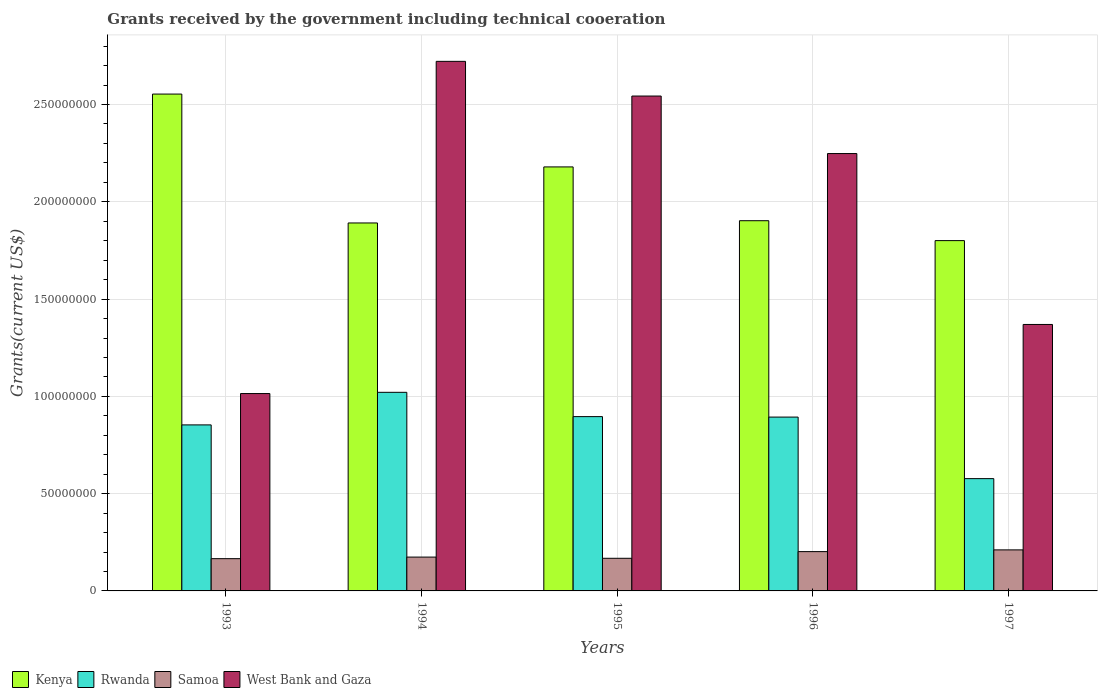How many different coloured bars are there?
Give a very brief answer. 4. How many groups of bars are there?
Make the answer very short. 5. What is the label of the 3rd group of bars from the left?
Offer a terse response. 1995. In how many cases, is the number of bars for a given year not equal to the number of legend labels?
Provide a succinct answer. 0. What is the total grants received by the government in West Bank and Gaza in 1996?
Ensure brevity in your answer.  2.25e+08. Across all years, what is the maximum total grants received by the government in Kenya?
Your answer should be compact. 2.55e+08. Across all years, what is the minimum total grants received by the government in Samoa?
Ensure brevity in your answer.  1.66e+07. In which year was the total grants received by the government in Kenya maximum?
Make the answer very short. 1993. What is the total total grants received by the government in Kenya in the graph?
Make the answer very short. 1.03e+09. What is the difference between the total grants received by the government in West Bank and Gaza in 1994 and that in 1997?
Offer a terse response. 1.35e+08. What is the difference between the total grants received by the government in Samoa in 1993 and the total grants received by the government in West Bank and Gaza in 1997?
Give a very brief answer. -1.20e+08. What is the average total grants received by the government in Samoa per year?
Keep it short and to the point. 1.84e+07. In the year 1994, what is the difference between the total grants received by the government in Rwanda and total grants received by the government in Kenya?
Your answer should be very brief. -8.70e+07. What is the ratio of the total grants received by the government in Samoa in 1995 to that in 1997?
Offer a terse response. 0.8. Is the total grants received by the government in Samoa in 1993 less than that in 1996?
Your answer should be compact. Yes. Is the difference between the total grants received by the government in Rwanda in 1994 and 1997 greater than the difference between the total grants received by the government in Kenya in 1994 and 1997?
Ensure brevity in your answer.  Yes. What is the difference between the highest and the second highest total grants received by the government in Rwanda?
Provide a short and direct response. 1.25e+07. What is the difference between the highest and the lowest total grants received by the government in Kenya?
Give a very brief answer. 7.53e+07. In how many years, is the total grants received by the government in Samoa greater than the average total grants received by the government in Samoa taken over all years?
Provide a short and direct response. 2. Is it the case that in every year, the sum of the total grants received by the government in Kenya and total grants received by the government in Rwanda is greater than the sum of total grants received by the government in Samoa and total grants received by the government in West Bank and Gaza?
Offer a very short reply. No. What does the 3rd bar from the left in 1993 represents?
Offer a terse response. Samoa. What does the 4th bar from the right in 1993 represents?
Provide a short and direct response. Kenya. How many bars are there?
Keep it short and to the point. 20. What is the difference between two consecutive major ticks on the Y-axis?
Make the answer very short. 5.00e+07. Are the values on the major ticks of Y-axis written in scientific E-notation?
Keep it short and to the point. No. Does the graph contain grids?
Ensure brevity in your answer.  Yes. What is the title of the graph?
Make the answer very short. Grants received by the government including technical cooeration. What is the label or title of the X-axis?
Give a very brief answer. Years. What is the label or title of the Y-axis?
Make the answer very short. Grants(current US$). What is the Grants(current US$) in Kenya in 1993?
Your answer should be compact. 2.55e+08. What is the Grants(current US$) in Rwanda in 1993?
Your response must be concise. 8.53e+07. What is the Grants(current US$) in Samoa in 1993?
Your answer should be very brief. 1.66e+07. What is the Grants(current US$) in West Bank and Gaza in 1993?
Make the answer very short. 1.01e+08. What is the Grants(current US$) in Kenya in 1994?
Your answer should be very brief. 1.89e+08. What is the Grants(current US$) in Rwanda in 1994?
Give a very brief answer. 1.02e+08. What is the Grants(current US$) of Samoa in 1994?
Provide a short and direct response. 1.74e+07. What is the Grants(current US$) of West Bank and Gaza in 1994?
Make the answer very short. 2.72e+08. What is the Grants(current US$) in Kenya in 1995?
Offer a terse response. 2.18e+08. What is the Grants(current US$) of Rwanda in 1995?
Ensure brevity in your answer.  8.96e+07. What is the Grants(current US$) in Samoa in 1995?
Provide a succinct answer. 1.68e+07. What is the Grants(current US$) in West Bank and Gaza in 1995?
Provide a succinct answer. 2.54e+08. What is the Grants(current US$) in Kenya in 1996?
Provide a succinct answer. 1.90e+08. What is the Grants(current US$) of Rwanda in 1996?
Offer a very short reply. 8.94e+07. What is the Grants(current US$) in Samoa in 1996?
Your answer should be very brief. 2.02e+07. What is the Grants(current US$) in West Bank and Gaza in 1996?
Give a very brief answer. 2.25e+08. What is the Grants(current US$) of Kenya in 1997?
Provide a short and direct response. 1.80e+08. What is the Grants(current US$) in Rwanda in 1997?
Offer a terse response. 5.77e+07. What is the Grants(current US$) of Samoa in 1997?
Provide a short and direct response. 2.11e+07. What is the Grants(current US$) in West Bank and Gaza in 1997?
Your answer should be compact. 1.37e+08. Across all years, what is the maximum Grants(current US$) in Kenya?
Provide a succinct answer. 2.55e+08. Across all years, what is the maximum Grants(current US$) in Rwanda?
Provide a succinct answer. 1.02e+08. Across all years, what is the maximum Grants(current US$) of Samoa?
Make the answer very short. 2.11e+07. Across all years, what is the maximum Grants(current US$) of West Bank and Gaza?
Provide a succinct answer. 2.72e+08. Across all years, what is the minimum Grants(current US$) of Kenya?
Provide a succinct answer. 1.80e+08. Across all years, what is the minimum Grants(current US$) in Rwanda?
Provide a short and direct response. 5.77e+07. Across all years, what is the minimum Grants(current US$) of Samoa?
Your answer should be compact. 1.66e+07. Across all years, what is the minimum Grants(current US$) of West Bank and Gaza?
Make the answer very short. 1.01e+08. What is the total Grants(current US$) in Kenya in the graph?
Provide a succinct answer. 1.03e+09. What is the total Grants(current US$) in Rwanda in the graph?
Offer a terse response. 4.24e+08. What is the total Grants(current US$) in Samoa in the graph?
Your response must be concise. 9.20e+07. What is the total Grants(current US$) in West Bank and Gaza in the graph?
Give a very brief answer. 9.90e+08. What is the difference between the Grants(current US$) of Kenya in 1993 and that in 1994?
Provide a short and direct response. 6.62e+07. What is the difference between the Grants(current US$) in Rwanda in 1993 and that in 1994?
Offer a very short reply. -1.67e+07. What is the difference between the Grants(current US$) in Samoa in 1993 and that in 1994?
Give a very brief answer. -8.10e+05. What is the difference between the Grants(current US$) of West Bank and Gaza in 1993 and that in 1994?
Offer a very short reply. -1.71e+08. What is the difference between the Grants(current US$) in Kenya in 1993 and that in 1995?
Provide a succinct answer. 3.74e+07. What is the difference between the Grants(current US$) of Rwanda in 1993 and that in 1995?
Your response must be concise. -4.25e+06. What is the difference between the Grants(current US$) in Samoa in 1993 and that in 1995?
Give a very brief answer. -1.90e+05. What is the difference between the Grants(current US$) in West Bank and Gaza in 1993 and that in 1995?
Provide a succinct answer. -1.53e+08. What is the difference between the Grants(current US$) in Kenya in 1993 and that in 1996?
Keep it short and to the point. 6.51e+07. What is the difference between the Grants(current US$) in Rwanda in 1993 and that in 1996?
Your response must be concise. -4.01e+06. What is the difference between the Grants(current US$) of Samoa in 1993 and that in 1996?
Provide a short and direct response. -3.62e+06. What is the difference between the Grants(current US$) in West Bank and Gaza in 1993 and that in 1996?
Provide a short and direct response. -1.23e+08. What is the difference between the Grants(current US$) in Kenya in 1993 and that in 1997?
Ensure brevity in your answer.  7.53e+07. What is the difference between the Grants(current US$) of Rwanda in 1993 and that in 1997?
Provide a succinct answer. 2.76e+07. What is the difference between the Grants(current US$) of Samoa in 1993 and that in 1997?
Your response must be concise. -4.51e+06. What is the difference between the Grants(current US$) of West Bank and Gaza in 1993 and that in 1997?
Your answer should be very brief. -3.55e+07. What is the difference between the Grants(current US$) of Kenya in 1994 and that in 1995?
Keep it short and to the point. -2.88e+07. What is the difference between the Grants(current US$) of Rwanda in 1994 and that in 1995?
Offer a very short reply. 1.25e+07. What is the difference between the Grants(current US$) of Samoa in 1994 and that in 1995?
Your answer should be very brief. 6.20e+05. What is the difference between the Grants(current US$) of West Bank and Gaza in 1994 and that in 1995?
Ensure brevity in your answer.  1.78e+07. What is the difference between the Grants(current US$) in Kenya in 1994 and that in 1996?
Make the answer very short. -1.16e+06. What is the difference between the Grants(current US$) of Rwanda in 1994 and that in 1996?
Give a very brief answer. 1.27e+07. What is the difference between the Grants(current US$) of Samoa in 1994 and that in 1996?
Give a very brief answer. -2.81e+06. What is the difference between the Grants(current US$) of West Bank and Gaza in 1994 and that in 1996?
Give a very brief answer. 4.74e+07. What is the difference between the Grants(current US$) in Kenya in 1994 and that in 1997?
Your answer should be compact. 9.07e+06. What is the difference between the Grants(current US$) in Rwanda in 1994 and that in 1997?
Provide a succinct answer. 4.44e+07. What is the difference between the Grants(current US$) of Samoa in 1994 and that in 1997?
Offer a very short reply. -3.70e+06. What is the difference between the Grants(current US$) in West Bank and Gaza in 1994 and that in 1997?
Provide a short and direct response. 1.35e+08. What is the difference between the Grants(current US$) in Kenya in 1995 and that in 1996?
Keep it short and to the point. 2.76e+07. What is the difference between the Grants(current US$) in Samoa in 1995 and that in 1996?
Offer a very short reply. -3.43e+06. What is the difference between the Grants(current US$) in West Bank and Gaza in 1995 and that in 1996?
Make the answer very short. 2.96e+07. What is the difference between the Grants(current US$) in Kenya in 1995 and that in 1997?
Provide a succinct answer. 3.79e+07. What is the difference between the Grants(current US$) of Rwanda in 1995 and that in 1997?
Provide a short and direct response. 3.19e+07. What is the difference between the Grants(current US$) of Samoa in 1995 and that in 1997?
Make the answer very short. -4.32e+06. What is the difference between the Grants(current US$) in West Bank and Gaza in 1995 and that in 1997?
Provide a succinct answer. 1.17e+08. What is the difference between the Grants(current US$) in Kenya in 1996 and that in 1997?
Give a very brief answer. 1.02e+07. What is the difference between the Grants(current US$) in Rwanda in 1996 and that in 1997?
Provide a succinct answer. 3.16e+07. What is the difference between the Grants(current US$) of Samoa in 1996 and that in 1997?
Offer a very short reply. -8.90e+05. What is the difference between the Grants(current US$) in West Bank and Gaza in 1996 and that in 1997?
Ensure brevity in your answer.  8.78e+07. What is the difference between the Grants(current US$) of Kenya in 1993 and the Grants(current US$) of Rwanda in 1994?
Make the answer very short. 1.53e+08. What is the difference between the Grants(current US$) in Kenya in 1993 and the Grants(current US$) in Samoa in 1994?
Provide a succinct answer. 2.38e+08. What is the difference between the Grants(current US$) in Kenya in 1993 and the Grants(current US$) in West Bank and Gaza in 1994?
Give a very brief answer. -1.68e+07. What is the difference between the Grants(current US$) in Rwanda in 1993 and the Grants(current US$) in Samoa in 1994?
Make the answer very short. 6.80e+07. What is the difference between the Grants(current US$) in Rwanda in 1993 and the Grants(current US$) in West Bank and Gaza in 1994?
Offer a very short reply. -1.87e+08. What is the difference between the Grants(current US$) in Samoa in 1993 and the Grants(current US$) in West Bank and Gaza in 1994?
Offer a very short reply. -2.56e+08. What is the difference between the Grants(current US$) of Kenya in 1993 and the Grants(current US$) of Rwanda in 1995?
Give a very brief answer. 1.66e+08. What is the difference between the Grants(current US$) of Kenya in 1993 and the Grants(current US$) of Samoa in 1995?
Your answer should be compact. 2.39e+08. What is the difference between the Grants(current US$) in Kenya in 1993 and the Grants(current US$) in West Bank and Gaza in 1995?
Keep it short and to the point. 1.01e+06. What is the difference between the Grants(current US$) of Rwanda in 1993 and the Grants(current US$) of Samoa in 1995?
Your answer should be compact. 6.86e+07. What is the difference between the Grants(current US$) in Rwanda in 1993 and the Grants(current US$) in West Bank and Gaza in 1995?
Provide a short and direct response. -1.69e+08. What is the difference between the Grants(current US$) in Samoa in 1993 and the Grants(current US$) in West Bank and Gaza in 1995?
Provide a succinct answer. -2.38e+08. What is the difference between the Grants(current US$) in Kenya in 1993 and the Grants(current US$) in Rwanda in 1996?
Provide a short and direct response. 1.66e+08. What is the difference between the Grants(current US$) in Kenya in 1993 and the Grants(current US$) in Samoa in 1996?
Ensure brevity in your answer.  2.35e+08. What is the difference between the Grants(current US$) of Kenya in 1993 and the Grants(current US$) of West Bank and Gaza in 1996?
Ensure brevity in your answer.  3.06e+07. What is the difference between the Grants(current US$) in Rwanda in 1993 and the Grants(current US$) in Samoa in 1996?
Provide a short and direct response. 6.51e+07. What is the difference between the Grants(current US$) of Rwanda in 1993 and the Grants(current US$) of West Bank and Gaza in 1996?
Your answer should be compact. -1.39e+08. What is the difference between the Grants(current US$) in Samoa in 1993 and the Grants(current US$) in West Bank and Gaza in 1996?
Keep it short and to the point. -2.08e+08. What is the difference between the Grants(current US$) in Kenya in 1993 and the Grants(current US$) in Rwanda in 1997?
Your answer should be very brief. 1.98e+08. What is the difference between the Grants(current US$) in Kenya in 1993 and the Grants(current US$) in Samoa in 1997?
Your response must be concise. 2.34e+08. What is the difference between the Grants(current US$) of Kenya in 1993 and the Grants(current US$) of West Bank and Gaza in 1997?
Your answer should be very brief. 1.18e+08. What is the difference between the Grants(current US$) in Rwanda in 1993 and the Grants(current US$) in Samoa in 1997?
Keep it short and to the point. 6.42e+07. What is the difference between the Grants(current US$) in Rwanda in 1993 and the Grants(current US$) in West Bank and Gaza in 1997?
Offer a terse response. -5.16e+07. What is the difference between the Grants(current US$) in Samoa in 1993 and the Grants(current US$) in West Bank and Gaza in 1997?
Offer a terse response. -1.20e+08. What is the difference between the Grants(current US$) of Kenya in 1994 and the Grants(current US$) of Rwanda in 1995?
Offer a terse response. 9.95e+07. What is the difference between the Grants(current US$) of Kenya in 1994 and the Grants(current US$) of Samoa in 1995?
Provide a succinct answer. 1.72e+08. What is the difference between the Grants(current US$) of Kenya in 1994 and the Grants(current US$) of West Bank and Gaza in 1995?
Offer a terse response. -6.52e+07. What is the difference between the Grants(current US$) in Rwanda in 1994 and the Grants(current US$) in Samoa in 1995?
Make the answer very short. 8.53e+07. What is the difference between the Grants(current US$) in Rwanda in 1994 and the Grants(current US$) in West Bank and Gaza in 1995?
Your answer should be very brief. -1.52e+08. What is the difference between the Grants(current US$) of Samoa in 1994 and the Grants(current US$) of West Bank and Gaza in 1995?
Offer a terse response. -2.37e+08. What is the difference between the Grants(current US$) of Kenya in 1994 and the Grants(current US$) of Rwanda in 1996?
Offer a terse response. 9.98e+07. What is the difference between the Grants(current US$) in Kenya in 1994 and the Grants(current US$) in Samoa in 1996?
Make the answer very short. 1.69e+08. What is the difference between the Grants(current US$) in Kenya in 1994 and the Grants(current US$) in West Bank and Gaza in 1996?
Offer a very short reply. -3.57e+07. What is the difference between the Grants(current US$) of Rwanda in 1994 and the Grants(current US$) of Samoa in 1996?
Ensure brevity in your answer.  8.19e+07. What is the difference between the Grants(current US$) in Rwanda in 1994 and the Grants(current US$) in West Bank and Gaza in 1996?
Offer a very short reply. -1.23e+08. What is the difference between the Grants(current US$) in Samoa in 1994 and the Grants(current US$) in West Bank and Gaza in 1996?
Your response must be concise. -2.07e+08. What is the difference between the Grants(current US$) in Kenya in 1994 and the Grants(current US$) in Rwanda in 1997?
Offer a terse response. 1.31e+08. What is the difference between the Grants(current US$) of Kenya in 1994 and the Grants(current US$) of Samoa in 1997?
Keep it short and to the point. 1.68e+08. What is the difference between the Grants(current US$) in Kenya in 1994 and the Grants(current US$) in West Bank and Gaza in 1997?
Offer a very short reply. 5.22e+07. What is the difference between the Grants(current US$) of Rwanda in 1994 and the Grants(current US$) of Samoa in 1997?
Make the answer very short. 8.10e+07. What is the difference between the Grants(current US$) of Rwanda in 1994 and the Grants(current US$) of West Bank and Gaza in 1997?
Offer a terse response. -3.49e+07. What is the difference between the Grants(current US$) in Samoa in 1994 and the Grants(current US$) in West Bank and Gaza in 1997?
Ensure brevity in your answer.  -1.20e+08. What is the difference between the Grants(current US$) in Kenya in 1995 and the Grants(current US$) in Rwanda in 1996?
Your answer should be very brief. 1.29e+08. What is the difference between the Grants(current US$) in Kenya in 1995 and the Grants(current US$) in Samoa in 1996?
Offer a very short reply. 1.98e+08. What is the difference between the Grants(current US$) in Kenya in 1995 and the Grants(current US$) in West Bank and Gaza in 1996?
Give a very brief answer. -6.87e+06. What is the difference between the Grants(current US$) in Rwanda in 1995 and the Grants(current US$) in Samoa in 1996?
Ensure brevity in your answer.  6.94e+07. What is the difference between the Grants(current US$) in Rwanda in 1995 and the Grants(current US$) in West Bank and Gaza in 1996?
Your answer should be compact. -1.35e+08. What is the difference between the Grants(current US$) of Samoa in 1995 and the Grants(current US$) of West Bank and Gaza in 1996?
Ensure brevity in your answer.  -2.08e+08. What is the difference between the Grants(current US$) in Kenya in 1995 and the Grants(current US$) in Rwanda in 1997?
Offer a very short reply. 1.60e+08. What is the difference between the Grants(current US$) in Kenya in 1995 and the Grants(current US$) in Samoa in 1997?
Make the answer very short. 1.97e+08. What is the difference between the Grants(current US$) of Kenya in 1995 and the Grants(current US$) of West Bank and Gaza in 1997?
Offer a terse response. 8.10e+07. What is the difference between the Grants(current US$) of Rwanda in 1995 and the Grants(current US$) of Samoa in 1997?
Your answer should be compact. 6.85e+07. What is the difference between the Grants(current US$) of Rwanda in 1995 and the Grants(current US$) of West Bank and Gaza in 1997?
Provide a succinct answer. -4.74e+07. What is the difference between the Grants(current US$) of Samoa in 1995 and the Grants(current US$) of West Bank and Gaza in 1997?
Your answer should be very brief. -1.20e+08. What is the difference between the Grants(current US$) in Kenya in 1996 and the Grants(current US$) in Rwanda in 1997?
Your answer should be very brief. 1.33e+08. What is the difference between the Grants(current US$) in Kenya in 1996 and the Grants(current US$) in Samoa in 1997?
Make the answer very short. 1.69e+08. What is the difference between the Grants(current US$) of Kenya in 1996 and the Grants(current US$) of West Bank and Gaza in 1997?
Offer a very short reply. 5.33e+07. What is the difference between the Grants(current US$) in Rwanda in 1996 and the Grants(current US$) in Samoa in 1997?
Provide a succinct answer. 6.83e+07. What is the difference between the Grants(current US$) in Rwanda in 1996 and the Grants(current US$) in West Bank and Gaza in 1997?
Provide a succinct answer. -4.76e+07. What is the difference between the Grants(current US$) of Samoa in 1996 and the Grants(current US$) of West Bank and Gaza in 1997?
Your response must be concise. -1.17e+08. What is the average Grants(current US$) in Kenya per year?
Offer a terse response. 2.07e+08. What is the average Grants(current US$) of Rwanda per year?
Provide a short and direct response. 8.48e+07. What is the average Grants(current US$) of Samoa per year?
Offer a very short reply. 1.84e+07. What is the average Grants(current US$) of West Bank and Gaza per year?
Keep it short and to the point. 1.98e+08. In the year 1993, what is the difference between the Grants(current US$) of Kenya and Grants(current US$) of Rwanda?
Make the answer very short. 1.70e+08. In the year 1993, what is the difference between the Grants(current US$) of Kenya and Grants(current US$) of Samoa?
Your answer should be very brief. 2.39e+08. In the year 1993, what is the difference between the Grants(current US$) in Kenya and Grants(current US$) in West Bank and Gaza?
Offer a terse response. 1.54e+08. In the year 1993, what is the difference between the Grants(current US$) of Rwanda and Grants(current US$) of Samoa?
Offer a terse response. 6.88e+07. In the year 1993, what is the difference between the Grants(current US$) of Rwanda and Grants(current US$) of West Bank and Gaza?
Your answer should be very brief. -1.61e+07. In the year 1993, what is the difference between the Grants(current US$) in Samoa and Grants(current US$) in West Bank and Gaza?
Provide a succinct answer. -8.49e+07. In the year 1994, what is the difference between the Grants(current US$) in Kenya and Grants(current US$) in Rwanda?
Ensure brevity in your answer.  8.70e+07. In the year 1994, what is the difference between the Grants(current US$) in Kenya and Grants(current US$) in Samoa?
Give a very brief answer. 1.72e+08. In the year 1994, what is the difference between the Grants(current US$) in Kenya and Grants(current US$) in West Bank and Gaza?
Offer a terse response. -8.31e+07. In the year 1994, what is the difference between the Grants(current US$) in Rwanda and Grants(current US$) in Samoa?
Your response must be concise. 8.47e+07. In the year 1994, what is the difference between the Grants(current US$) in Rwanda and Grants(current US$) in West Bank and Gaza?
Provide a succinct answer. -1.70e+08. In the year 1994, what is the difference between the Grants(current US$) of Samoa and Grants(current US$) of West Bank and Gaza?
Provide a succinct answer. -2.55e+08. In the year 1995, what is the difference between the Grants(current US$) in Kenya and Grants(current US$) in Rwanda?
Provide a short and direct response. 1.28e+08. In the year 1995, what is the difference between the Grants(current US$) of Kenya and Grants(current US$) of Samoa?
Keep it short and to the point. 2.01e+08. In the year 1995, what is the difference between the Grants(current US$) of Kenya and Grants(current US$) of West Bank and Gaza?
Make the answer very short. -3.64e+07. In the year 1995, what is the difference between the Grants(current US$) of Rwanda and Grants(current US$) of Samoa?
Provide a succinct answer. 7.28e+07. In the year 1995, what is the difference between the Grants(current US$) of Rwanda and Grants(current US$) of West Bank and Gaza?
Ensure brevity in your answer.  -1.65e+08. In the year 1995, what is the difference between the Grants(current US$) of Samoa and Grants(current US$) of West Bank and Gaza?
Your answer should be very brief. -2.38e+08. In the year 1996, what is the difference between the Grants(current US$) in Kenya and Grants(current US$) in Rwanda?
Make the answer very short. 1.01e+08. In the year 1996, what is the difference between the Grants(current US$) in Kenya and Grants(current US$) in Samoa?
Offer a terse response. 1.70e+08. In the year 1996, what is the difference between the Grants(current US$) in Kenya and Grants(current US$) in West Bank and Gaza?
Provide a succinct answer. -3.45e+07. In the year 1996, what is the difference between the Grants(current US$) of Rwanda and Grants(current US$) of Samoa?
Provide a succinct answer. 6.92e+07. In the year 1996, what is the difference between the Grants(current US$) of Rwanda and Grants(current US$) of West Bank and Gaza?
Offer a terse response. -1.35e+08. In the year 1996, what is the difference between the Grants(current US$) in Samoa and Grants(current US$) in West Bank and Gaza?
Offer a very short reply. -2.05e+08. In the year 1997, what is the difference between the Grants(current US$) in Kenya and Grants(current US$) in Rwanda?
Offer a terse response. 1.22e+08. In the year 1997, what is the difference between the Grants(current US$) of Kenya and Grants(current US$) of Samoa?
Your answer should be compact. 1.59e+08. In the year 1997, what is the difference between the Grants(current US$) of Kenya and Grants(current US$) of West Bank and Gaza?
Your answer should be compact. 4.31e+07. In the year 1997, what is the difference between the Grants(current US$) in Rwanda and Grants(current US$) in Samoa?
Provide a short and direct response. 3.66e+07. In the year 1997, what is the difference between the Grants(current US$) of Rwanda and Grants(current US$) of West Bank and Gaza?
Provide a short and direct response. -7.92e+07. In the year 1997, what is the difference between the Grants(current US$) in Samoa and Grants(current US$) in West Bank and Gaza?
Your answer should be compact. -1.16e+08. What is the ratio of the Grants(current US$) in Kenya in 1993 to that in 1994?
Offer a very short reply. 1.35. What is the ratio of the Grants(current US$) of Rwanda in 1993 to that in 1994?
Ensure brevity in your answer.  0.84. What is the ratio of the Grants(current US$) of Samoa in 1993 to that in 1994?
Your answer should be very brief. 0.95. What is the ratio of the Grants(current US$) of West Bank and Gaza in 1993 to that in 1994?
Your answer should be compact. 0.37. What is the ratio of the Grants(current US$) in Kenya in 1993 to that in 1995?
Keep it short and to the point. 1.17. What is the ratio of the Grants(current US$) of Rwanda in 1993 to that in 1995?
Your response must be concise. 0.95. What is the ratio of the Grants(current US$) of Samoa in 1993 to that in 1995?
Your response must be concise. 0.99. What is the ratio of the Grants(current US$) in West Bank and Gaza in 1993 to that in 1995?
Your answer should be very brief. 0.4. What is the ratio of the Grants(current US$) in Kenya in 1993 to that in 1996?
Your answer should be compact. 1.34. What is the ratio of the Grants(current US$) in Rwanda in 1993 to that in 1996?
Give a very brief answer. 0.96. What is the ratio of the Grants(current US$) in Samoa in 1993 to that in 1996?
Keep it short and to the point. 0.82. What is the ratio of the Grants(current US$) in West Bank and Gaza in 1993 to that in 1996?
Ensure brevity in your answer.  0.45. What is the ratio of the Grants(current US$) in Kenya in 1993 to that in 1997?
Offer a terse response. 1.42. What is the ratio of the Grants(current US$) in Rwanda in 1993 to that in 1997?
Provide a succinct answer. 1.48. What is the ratio of the Grants(current US$) of Samoa in 1993 to that in 1997?
Your answer should be very brief. 0.79. What is the ratio of the Grants(current US$) in West Bank and Gaza in 1993 to that in 1997?
Keep it short and to the point. 0.74. What is the ratio of the Grants(current US$) in Kenya in 1994 to that in 1995?
Keep it short and to the point. 0.87. What is the ratio of the Grants(current US$) of Rwanda in 1994 to that in 1995?
Offer a very short reply. 1.14. What is the ratio of the Grants(current US$) in West Bank and Gaza in 1994 to that in 1995?
Offer a very short reply. 1.07. What is the ratio of the Grants(current US$) in Kenya in 1994 to that in 1996?
Your answer should be compact. 0.99. What is the ratio of the Grants(current US$) of Rwanda in 1994 to that in 1996?
Your answer should be very brief. 1.14. What is the ratio of the Grants(current US$) of Samoa in 1994 to that in 1996?
Offer a terse response. 0.86. What is the ratio of the Grants(current US$) in West Bank and Gaza in 1994 to that in 1996?
Give a very brief answer. 1.21. What is the ratio of the Grants(current US$) of Kenya in 1994 to that in 1997?
Ensure brevity in your answer.  1.05. What is the ratio of the Grants(current US$) of Rwanda in 1994 to that in 1997?
Your response must be concise. 1.77. What is the ratio of the Grants(current US$) in Samoa in 1994 to that in 1997?
Ensure brevity in your answer.  0.82. What is the ratio of the Grants(current US$) in West Bank and Gaza in 1994 to that in 1997?
Your answer should be compact. 1.99. What is the ratio of the Grants(current US$) in Kenya in 1995 to that in 1996?
Ensure brevity in your answer.  1.15. What is the ratio of the Grants(current US$) in Samoa in 1995 to that in 1996?
Your answer should be very brief. 0.83. What is the ratio of the Grants(current US$) in West Bank and Gaza in 1995 to that in 1996?
Offer a very short reply. 1.13. What is the ratio of the Grants(current US$) in Kenya in 1995 to that in 1997?
Your response must be concise. 1.21. What is the ratio of the Grants(current US$) of Rwanda in 1995 to that in 1997?
Make the answer very short. 1.55. What is the ratio of the Grants(current US$) in Samoa in 1995 to that in 1997?
Keep it short and to the point. 0.8. What is the ratio of the Grants(current US$) of West Bank and Gaza in 1995 to that in 1997?
Provide a succinct answer. 1.86. What is the ratio of the Grants(current US$) in Kenya in 1996 to that in 1997?
Your answer should be compact. 1.06. What is the ratio of the Grants(current US$) of Rwanda in 1996 to that in 1997?
Your answer should be very brief. 1.55. What is the ratio of the Grants(current US$) in Samoa in 1996 to that in 1997?
Your answer should be compact. 0.96. What is the ratio of the Grants(current US$) in West Bank and Gaza in 1996 to that in 1997?
Offer a very short reply. 1.64. What is the difference between the highest and the second highest Grants(current US$) of Kenya?
Make the answer very short. 3.74e+07. What is the difference between the highest and the second highest Grants(current US$) in Rwanda?
Your answer should be very brief. 1.25e+07. What is the difference between the highest and the second highest Grants(current US$) in Samoa?
Offer a terse response. 8.90e+05. What is the difference between the highest and the second highest Grants(current US$) of West Bank and Gaza?
Offer a terse response. 1.78e+07. What is the difference between the highest and the lowest Grants(current US$) in Kenya?
Offer a very short reply. 7.53e+07. What is the difference between the highest and the lowest Grants(current US$) in Rwanda?
Make the answer very short. 4.44e+07. What is the difference between the highest and the lowest Grants(current US$) of Samoa?
Offer a terse response. 4.51e+06. What is the difference between the highest and the lowest Grants(current US$) of West Bank and Gaza?
Ensure brevity in your answer.  1.71e+08. 